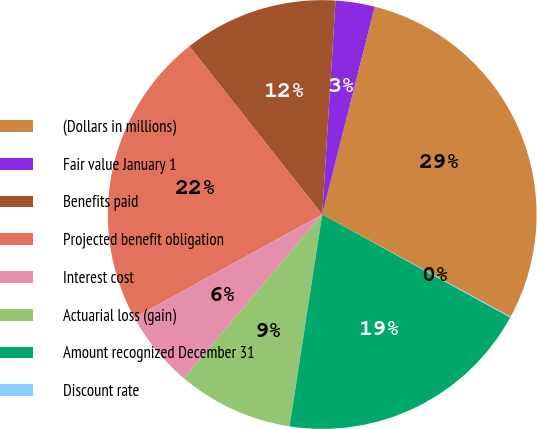Convert chart. <chart><loc_0><loc_0><loc_500><loc_500><pie_chart><fcel>(Dollars in millions)<fcel>Fair value January 1<fcel>Benefits paid<fcel>Projected benefit obligation<fcel>Interest cost<fcel>Actuarial loss (gain)<fcel>Amount recognized December 31<fcel>Discount rate<nl><fcel>28.97%<fcel>2.95%<fcel>11.63%<fcel>22.35%<fcel>5.84%<fcel>8.74%<fcel>19.46%<fcel>0.06%<nl></chart> 